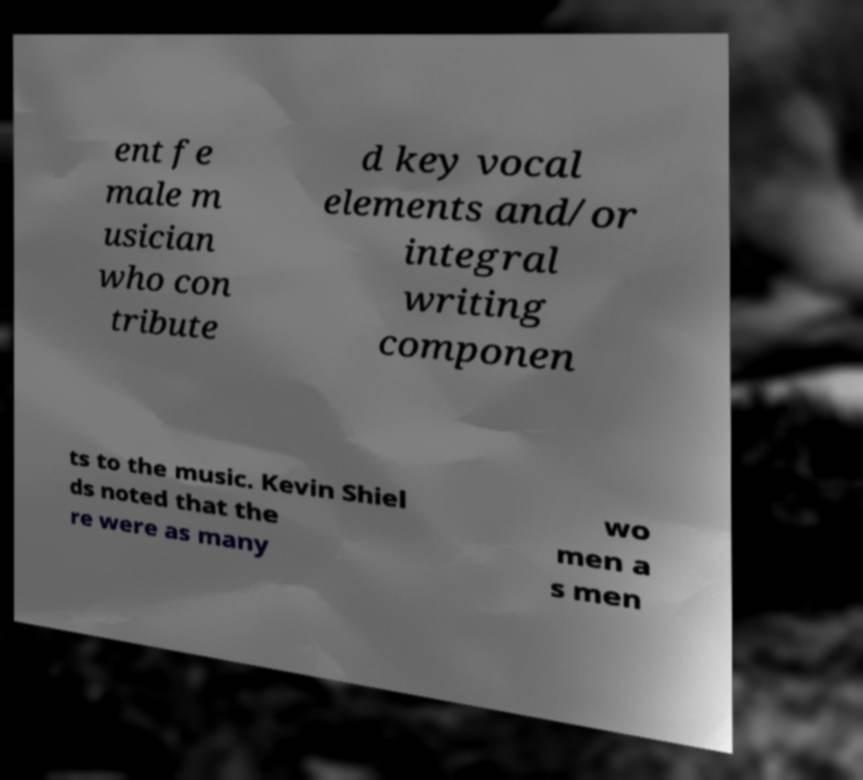There's text embedded in this image that I need extracted. Can you transcribe it verbatim? ent fe male m usician who con tribute d key vocal elements and/or integral writing componen ts to the music. Kevin Shiel ds noted that the re were as many wo men a s men 